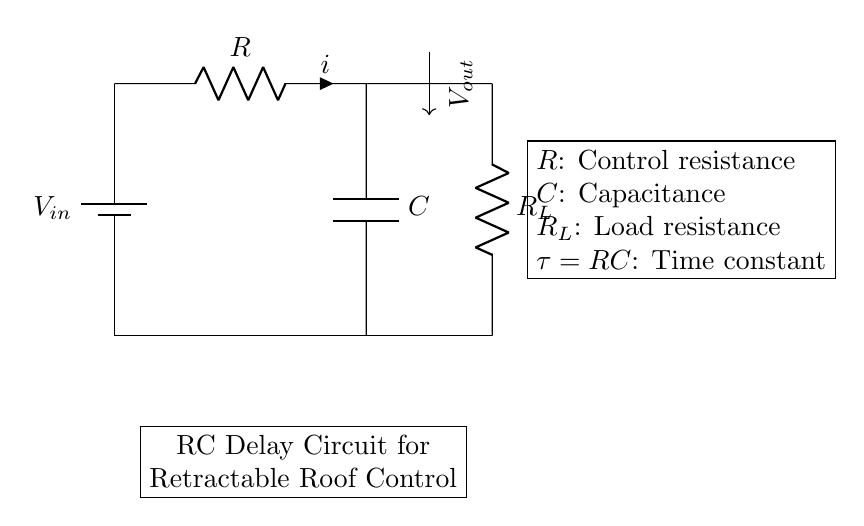What is the purpose of the capacitor in this circuit? The capacitor in this circuit stores electrical energy and releases it slowly, helping to create a delay in the voltage output as the roof mechanism is activated.
Answer: delay What is the value of the time constant τ in this circuit? The time constant τ is calculated as the product of resistance R and capacitance C, represented by the formula τ = RC. This shows how long it takes for the voltage to charge to about 63% of its final value.
Answer: RC What is the role of the load resistance R_L? The load resistance R_L serves as a component that uses the output voltage, impacting how quickly the capacitor discharges and thus affecting the delay in operation of the retractable roof.
Answer: discharge rate What direction does the current flow in this circuit? Current flows from the positive terminal of the battery through the resistor R, then through the capacitor C and finally through the load resistance R_L before returning to the battery.
Answer: clockwise What happens to the output voltage V_out after the capacitor is fully charged? Once the capacitor is fully charged, the output voltage V_out stabilizes and becomes constant, effectively controlling the retractable roof mechanism without further adjustment.
Answer: stable How many resistors are present in this circuit? There are two resistors present: R and R_L.
Answer: two 